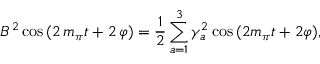<formula> <loc_0><loc_0><loc_500><loc_500>B ^ { 2 } \cos \, ( 2 \, m _ { \pi } t + 2 \, \varphi ) = { \frac { 1 } { 2 } } \sum _ { a = 1 } ^ { 3 } \gamma _ { a } ^ { 2 } \cos \, ( 2 m _ { \pi } t + 2 \varphi ) ,</formula> 